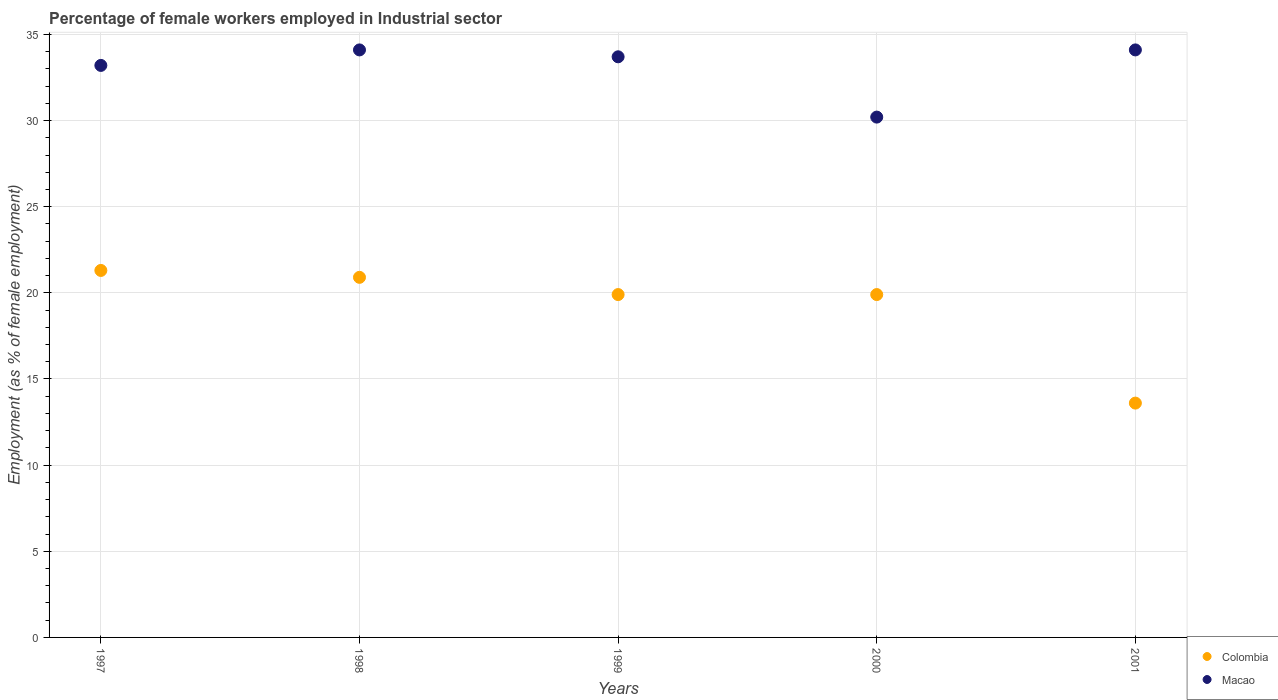What is the percentage of females employed in Industrial sector in Colombia in 2000?
Your response must be concise. 19.9. Across all years, what is the maximum percentage of females employed in Industrial sector in Colombia?
Your answer should be very brief. 21.3. Across all years, what is the minimum percentage of females employed in Industrial sector in Colombia?
Your response must be concise. 13.6. In which year was the percentage of females employed in Industrial sector in Colombia maximum?
Offer a very short reply. 1997. In which year was the percentage of females employed in Industrial sector in Colombia minimum?
Give a very brief answer. 2001. What is the total percentage of females employed in Industrial sector in Colombia in the graph?
Keep it short and to the point. 95.6. What is the difference between the percentage of females employed in Industrial sector in Macao in 1998 and that in 1999?
Your answer should be very brief. 0.4. What is the difference between the percentage of females employed in Industrial sector in Macao in 1999 and the percentage of females employed in Industrial sector in Colombia in 2001?
Keep it short and to the point. 20.1. What is the average percentage of females employed in Industrial sector in Colombia per year?
Your answer should be very brief. 19.12. In the year 2000, what is the difference between the percentage of females employed in Industrial sector in Colombia and percentage of females employed in Industrial sector in Macao?
Provide a short and direct response. -10.3. In how many years, is the percentage of females employed in Industrial sector in Macao greater than 8 %?
Provide a short and direct response. 5. What is the ratio of the percentage of females employed in Industrial sector in Colombia in 1998 to that in 2000?
Your answer should be compact. 1.05. Is the percentage of females employed in Industrial sector in Macao in 1998 less than that in 2001?
Your response must be concise. No. Is the difference between the percentage of females employed in Industrial sector in Colombia in 1998 and 2001 greater than the difference between the percentage of females employed in Industrial sector in Macao in 1998 and 2001?
Make the answer very short. Yes. What is the difference between the highest and the second highest percentage of females employed in Industrial sector in Colombia?
Your answer should be very brief. 0.4. What is the difference between the highest and the lowest percentage of females employed in Industrial sector in Colombia?
Your answer should be compact. 7.7. In how many years, is the percentage of females employed in Industrial sector in Macao greater than the average percentage of females employed in Industrial sector in Macao taken over all years?
Give a very brief answer. 4. Is the percentage of females employed in Industrial sector in Colombia strictly less than the percentage of females employed in Industrial sector in Macao over the years?
Keep it short and to the point. Yes. How many years are there in the graph?
Offer a terse response. 5. What is the difference between two consecutive major ticks on the Y-axis?
Provide a succinct answer. 5. Are the values on the major ticks of Y-axis written in scientific E-notation?
Provide a short and direct response. No. Does the graph contain grids?
Provide a succinct answer. Yes. How many legend labels are there?
Give a very brief answer. 2. What is the title of the graph?
Ensure brevity in your answer.  Percentage of female workers employed in Industrial sector. What is the label or title of the X-axis?
Your answer should be compact. Years. What is the label or title of the Y-axis?
Offer a terse response. Employment (as % of female employment). What is the Employment (as % of female employment) in Colombia in 1997?
Your answer should be very brief. 21.3. What is the Employment (as % of female employment) in Macao in 1997?
Provide a succinct answer. 33.2. What is the Employment (as % of female employment) of Colombia in 1998?
Provide a short and direct response. 20.9. What is the Employment (as % of female employment) in Macao in 1998?
Your response must be concise. 34.1. What is the Employment (as % of female employment) of Colombia in 1999?
Your answer should be compact. 19.9. What is the Employment (as % of female employment) in Macao in 1999?
Provide a succinct answer. 33.7. What is the Employment (as % of female employment) of Colombia in 2000?
Provide a short and direct response. 19.9. What is the Employment (as % of female employment) in Macao in 2000?
Provide a short and direct response. 30.2. What is the Employment (as % of female employment) in Colombia in 2001?
Provide a short and direct response. 13.6. What is the Employment (as % of female employment) in Macao in 2001?
Offer a terse response. 34.1. Across all years, what is the maximum Employment (as % of female employment) in Colombia?
Provide a succinct answer. 21.3. Across all years, what is the maximum Employment (as % of female employment) of Macao?
Offer a very short reply. 34.1. Across all years, what is the minimum Employment (as % of female employment) of Colombia?
Offer a very short reply. 13.6. Across all years, what is the minimum Employment (as % of female employment) in Macao?
Provide a succinct answer. 30.2. What is the total Employment (as % of female employment) of Colombia in the graph?
Make the answer very short. 95.6. What is the total Employment (as % of female employment) of Macao in the graph?
Give a very brief answer. 165.3. What is the difference between the Employment (as % of female employment) of Macao in 1997 and that in 1998?
Offer a terse response. -0.9. What is the difference between the Employment (as % of female employment) of Colombia in 1997 and that in 1999?
Offer a terse response. 1.4. What is the difference between the Employment (as % of female employment) in Colombia in 1997 and that in 2000?
Keep it short and to the point. 1.4. What is the difference between the Employment (as % of female employment) in Macao in 1997 and that in 2000?
Your answer should be compact. 3. What is the difference between the Employment (as % of female employment) in Macao in 1997 and that in 2001?
Offer a very short reply. -0.9. What is the difference between the Employment (as % of female employment) in Colombia in 1998 and that in 1999?
Provide a succinct answer. 1. What is the difference between the Employment (as % of female employment) of Macao in 1998 and that in 2001?
Give a very brief answer. 0. What is the difference between the Employment (as % of female employment) of Colombia in 1999 and that in 2000?
Your answer should be compact. 0. What is the difference between the Employment (as % of female employment) in Colombia in 1999 and that in 2001?
Keep it short and to the point. 6.3. What is the difference between the Employment (as % of female employment) in Macao in 1999 and that in 2001?
Your answer should be very brief. -0.4. What is the difference between the Employment (as % of female employment) of Colombia in 2000 and that in 2001?
Offer a terse response. 6.3. What is the difference between the Employment (as % of female employment) in Colombia in 1997 and the Employment (as % of female employment) in Macao in 1999?
Your answer should be very brief. -12.4. What is the difference between the Employment (as % of female employment) in Colombia in 1997 and the Employment (as % of female employment) in Macao in 2000?
Make the answer very short. -8.9. What is the difference between the Employment (as % of female employment) of Colombia in 1998 and the Employment (as % of female employment) of Macao in 2000?
Ensure brevity in your answer.  -9.3. What is the difference between the Employment (as % of female employment) of Colombia in 1998 and the Employment (as % of female employment) of Macao in 2001?
Provide a short and direct response. -13.2. What is the difference between the Employment (as % of female employment) of Colombia in 1999 and the Employment (as % of female employment) of Macao in 2000?
Your answer should be very brief. -10.3. What is the difference between the Employment (as % of female employment) of Colombia in 1999 and the Employment (as % of female employment) of Macao in 2001?
Ensure brevity in your answer.  -14.2. What is the average Employment (as % of female employment) in Colombia per year?
Your answer should be compact. 19.12. What is the average Employment (as % of female employment) of Macao per year?
Offer a very short reply. 33.06. In the year 1999, what is the difference between the Employment (as % of female employment) in Colombia and Employment (as % of female employment) in Macao?
Provide a succinct answer. -13.8. In the year 2001, what is the difference between the Employment (as % of female employment) in Colombia and Employment (as % of female employment) in Macao?
Your response must be concise. -20.5. What is the ratio of the Employment (as % of female employment) of Colombia in 1997 to that in 1998?
Ensure brevity in your answer.  1.02. What is the ratio of the Employment (as % of female employment) of Macao in 1997 to that in 1998?
Provide a succinct answer. 0.97. What is the ratio of the Employment (as % of female employment) in Colombia in 1997 to that in 1999?
Provide a succinct answer. 1.07. What is the ratio of the Employment (as % of female employment) in Macao in 1997 to that in 1999?
Keep it short and to the point. 0.99. What is the ratio of the Employment (as % of female employment) in Colombia in 1997 to that in 2000?
Your answer should be very brief. 1.07. What is the ratio of the Employment (as % of female employment) of Macao in 1997 to that in 2000?
Keep it short and to the point. 1.1. What is the ratio of the Employment (as % of female employment) of Colombia in 1997 to that in 2001?
Your answer should be compact. 1.57. What is the ratio of the Employment (as % of female employment) of Macao in 1997 to that in 2001?
Offer a terse response. 0.97. What is the ratio of the Employment (as % of female employment) of Colombia in 1998 to that in 1999?
Provide a short and direct response. 1.05. What is the ratio of the Employment (as % of female employment) in Macao in 1998 to that in 1999?
Keep it short and to the point. 1.01. What is the ratio of the Employment (as % of female employment) in Colombia in 1998 to that in 2000?
Keep it short and to the point. 1.05. What is the ratio of the Employment (as % of female employment) of Macao in 1998 to that in 2000?
Provide a succinct answer. 1.13. What is the ratio of the Employment (as % of female employment) in Colombia in 1998 to that in 2001?
Your answer should be very brief. 1.54. What is the ratio of the Employment (as % of female employment) of Macao in 1998 to that in 2001?
Provide a short and direct response. 1. What is the ratio of the Employment (as % of female employment) in Macao in 1999 to that in 2000?
Provide a short and direct response. 1.12. What is the ratio of the Employment (as % of female employment) of Colombia in 1999 to that in 2001?
Offer a very short reply. 1.46. What is the ratio of the Employment (as % of female employment) of Macao in 1999 to that in 2001?
Offer a very short reply. 0.99. What is the ratio of the Employment (as % of female employment) in Colombia in 2000 to that in 2001?
Offer a terse response. 1.46. What is the ratio of the Employment (as % of female employment) in Macao in 2000 to that in 2001?
Provide a short and direct response. 0.89. What is the difference between the highest and the lowest Employment (as % of female employment) of Colombia?
Offer a very short reply. 7.7. What is the difference between the highest and the lowest Employment (as % of female employment) of Macao?
Your answer should be compact. 3.9. 